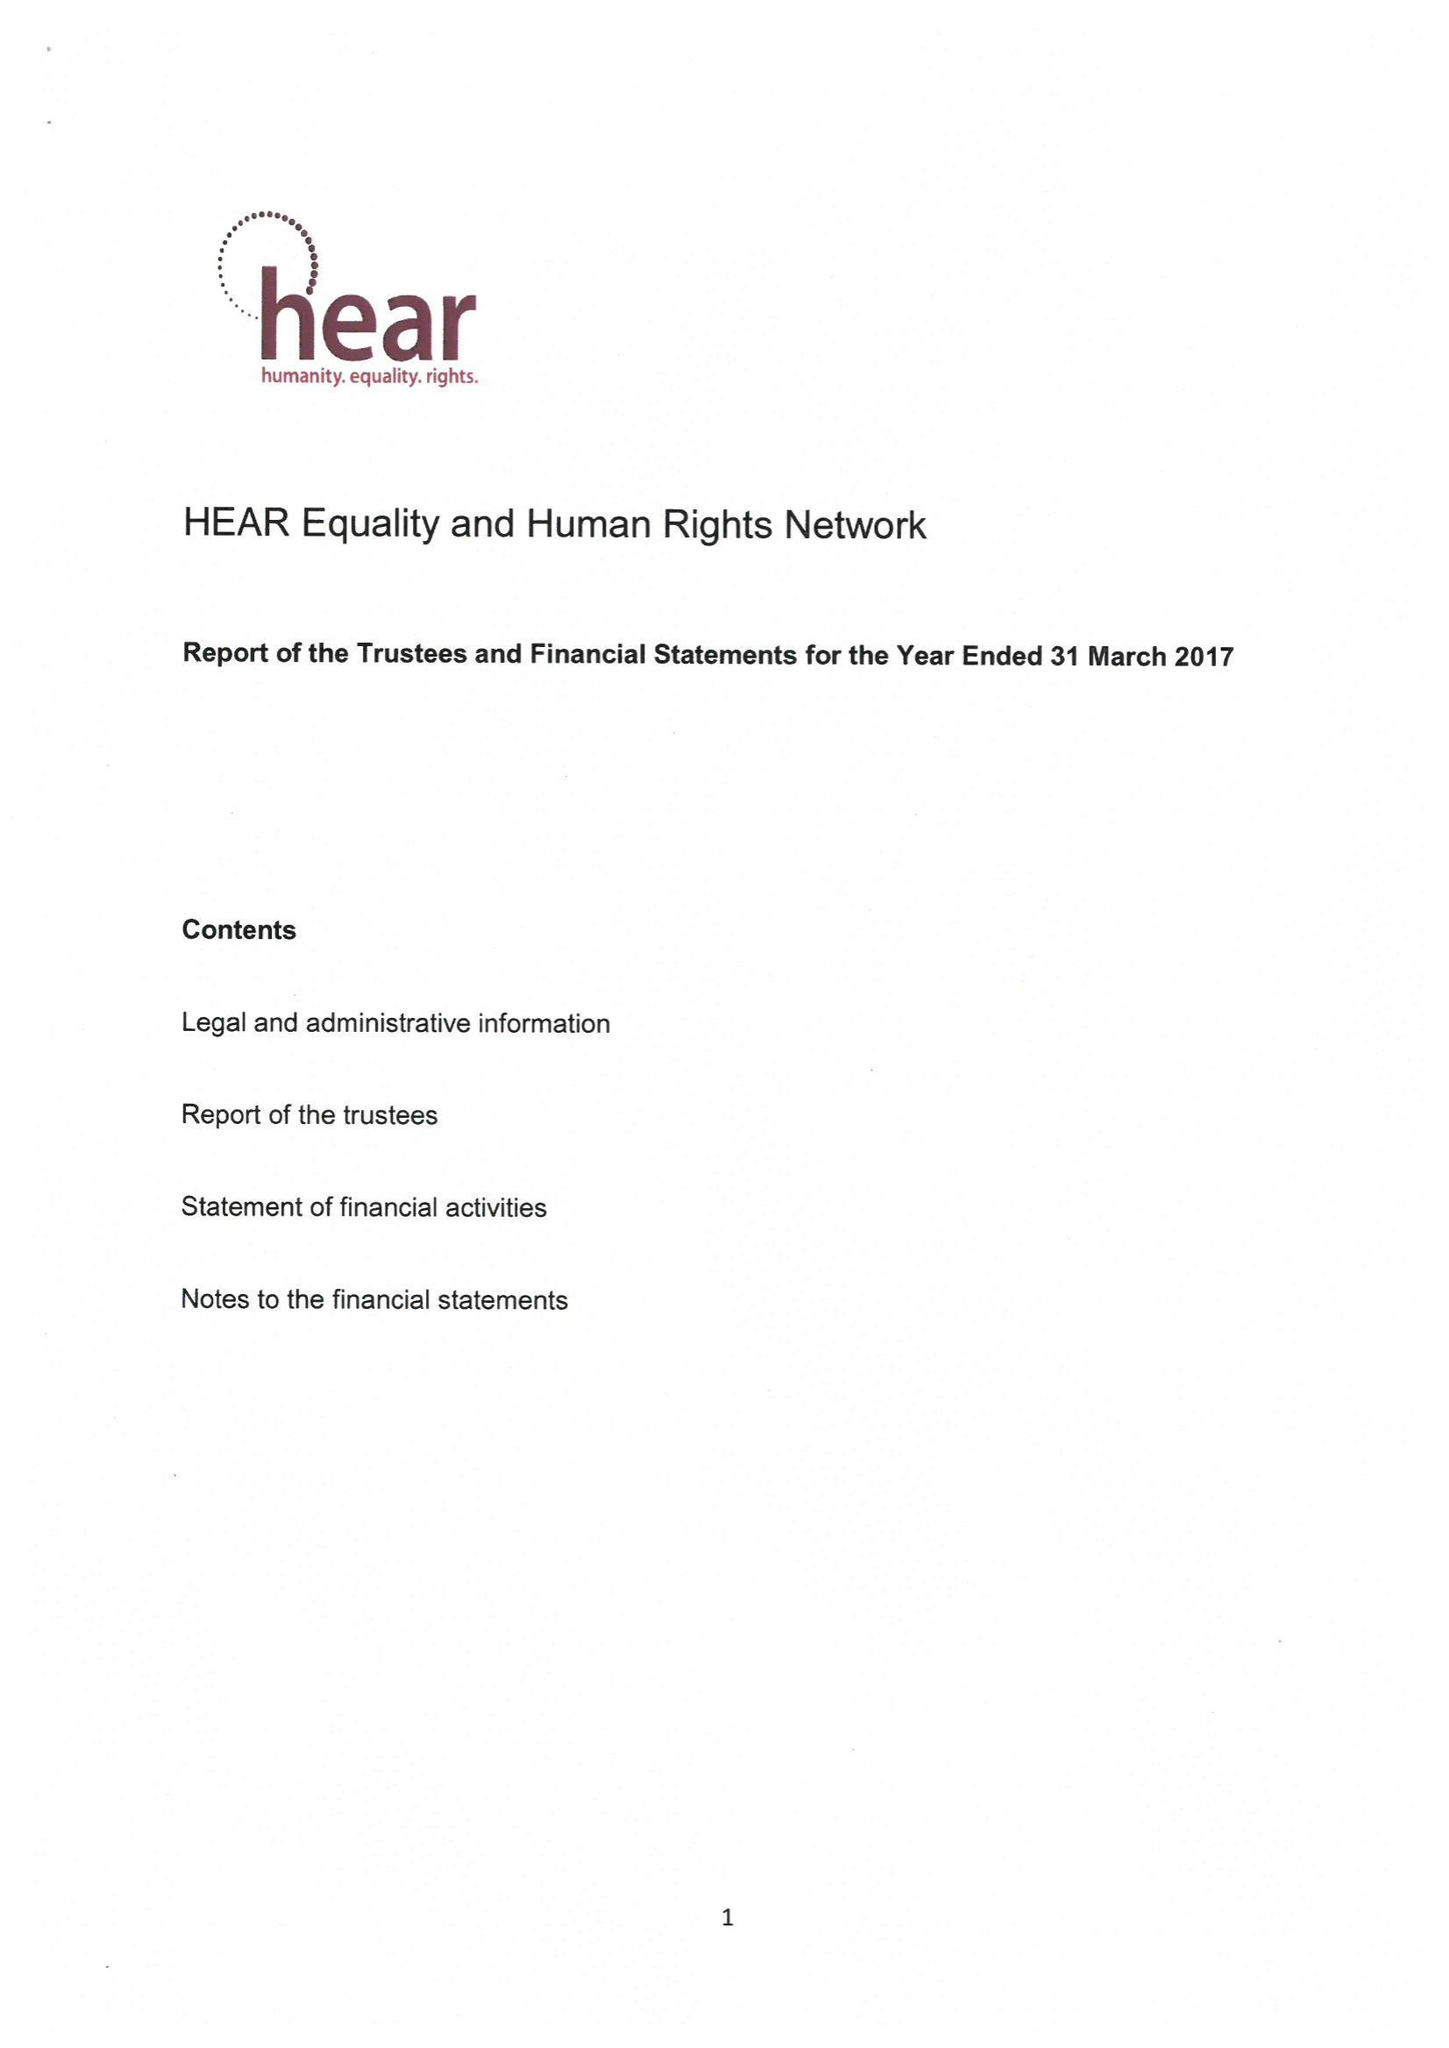What is the value for the income_annually_in_british_pounds?
Answer the question using a single word or phrase. None 